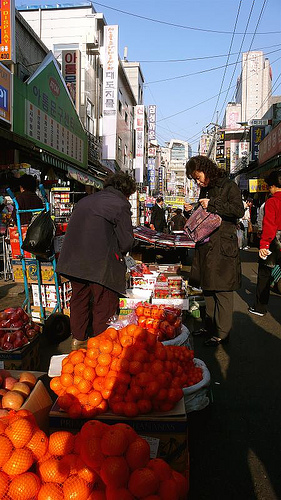Please provide the bounding box coordinate of the region this sentence describes: arm of a person. [0.72, 0.41, 0.77, 0.5] Please provide a short description for this region: [0.22, 0.82, 0.6, 1.0]. A bundle of oranges. Please provide a short description for this region: [0.49, 0.03, 0.67, 0.25]. Light blue is the color of the sky. Please provide a short description for this region: [0.41, 0.33, 0.51, 0.39]. The hair is short. Please provide a short description for this region: [0.32, 0.34, 0.71, 0.59]. Both women are wearing coats. Please provide the bounding box coordinate of the region this sentence describes: a blue hand dolly. [0.23, 0.36, 0.36, 0.69] Please provide the bounding box coordinate of the region this sentence describes: The oranges are in the bags. [0.23, 0.81, 0.63, 0.99] Please provide the bounding box coordinate of the region this sentence describes: Black bag on the hand truck. [0.26, 0.42, 0.34, 0.52] Please provide a short description for this region: [0.23, 0.36, 0.38, 0.66]. This is a blue carrier. Please provide a short description for this region: [0.58, 0.4, 0.6, 0.43]. Hand of a person. 